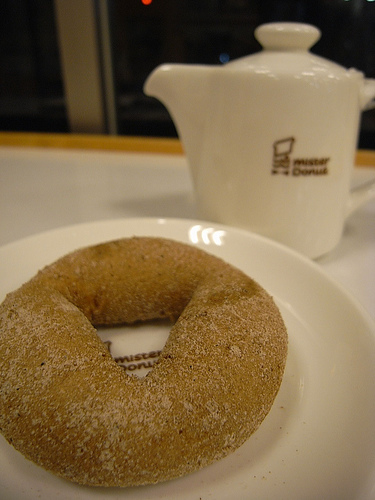<image>How many calories does the bagel have? It is unknown how many calories the bagel has. The calorie content of a bagel can range widely. How many calories does the bagel have? I don't know how many calories the bagel has. 